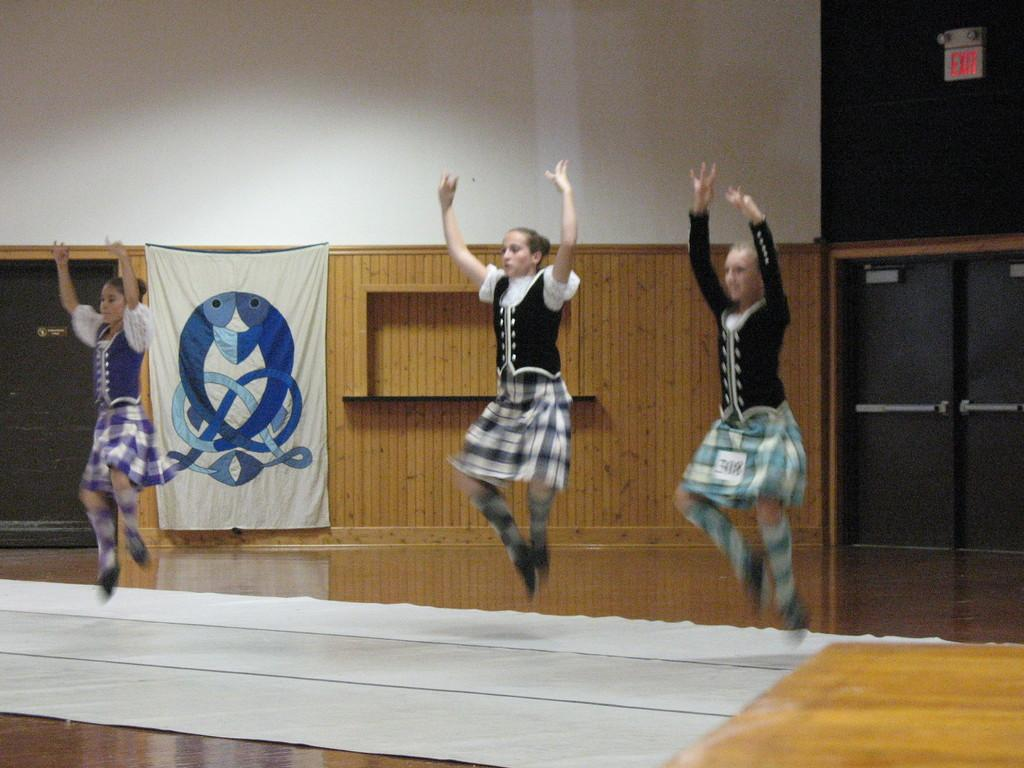How many people are in the image? There are 3 people in the image. What are the people doing in the image? The people are dancing. What are the people wearing in the image? They are wearing vase coats and skirts. What is beneath the people in the image? There is a white cloth beneath them. What can be seen in the background of the image? There is a banner, a door, and an exit sign board on the top in the background. How many dogs are present in the image? There are no dogs present in the image. What type of bird can be seen flying in the background of the image? There are no birds visible in the image. 